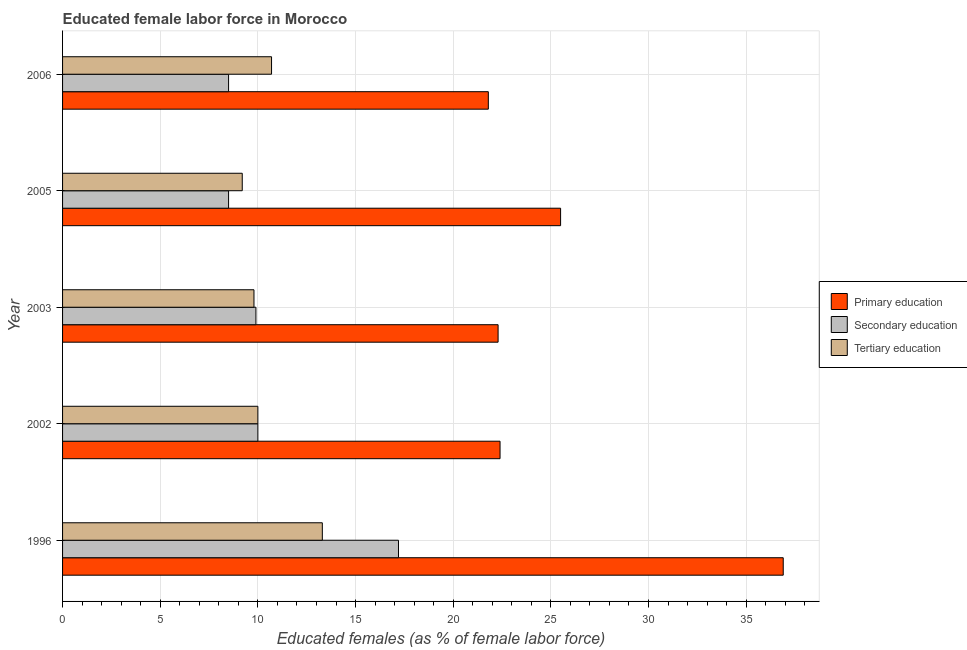How many different coloured bars are there?
Your answer should be very brief. 3. How many groups of bars are there?
Provide a succinct answer. 5. How many bars are there on the 5th tick from the bottom?
Your answer should be very brief. 3. What is the label of the 5th group of bars from the top?
Make the answer very short. 1996. What is the percentage of female labor force who received secondary education in 1996?
Provide a short and direct response. 17.2. Across all years, what is the maximum percentage of female labor force who received tertiary education?
Provide a short and direct response. 13.3. Across all years, what is the minimum percentage of female labor force who received secondary education?
Your answer should be very brief. 8.5. In which year was the percentage of female labor force who received tertiary education minimum?
Your response must be concise. 2005. What is the total percentage of female labor force who received tertiary education in the graph?
Your answer should be compact. 53. What is the difference between the percentage of female labor force who received primary education in 2005 and the percentage of female labor force who received tertiary education in 1996?
Your answer should be compact. 12.2. What is the average percentage of female labor force who received secondary education per year?
Offer a very short reply. 10.82. In the year 1996, what is the difference between the percentage of female labor force who received secondary education and percentage of female labor force who received primary education?
Your answer should be compact. -19.7. What is the ratio of the percentage of female labor force who received tertiary education in 2003 to that in 2006?
Make the answer very short. 0.92. Is the percentage of female labor force who received secondary education in 2002 less than that in 2003?
Your answer should be very brief. No. Is the difference between the percentage of female labor force who received tertiary education in 1996 and 2002 greater than the difference between the percentage of female labor force who received secondary education in 1996 and 2002?
Offer a terse response. No. What is the difference between the highest and the second highest percentage of female labor force who received secondary education?
Make the answer very short. 7.2. What is the difference between the highest and the lowest percentage of female labor force who received primary education?
Provide a succinct answer. 15.1. What does the 1st bar from the bottom in 1996 represents?
Your answer should be compact. Primary education. Is it the case that in every year, the sum of the percentage of female labor force who received primary education and percentage of female labor force who received secondary education is greater than the percentage of female labor force who received tertiary education?
Offer a very short reply. Yes. How many years are there in the graph?
Ensure brevity in your answer.  5. What is the difference between two consecutive major ticks on the X-axis?
Your answer should be very brief. 5. Are the values on the major ticks of X-axis written in scientific E-notation?
Keep it short and to the point. No. Does the graph contain any zero values?
Your answer should be compact. No. Where does the legend appear in the graph?
Keep it short and to the point. Center right. What is the title of the graph?
Offer a terse response. Educated female labor force in Morocco. What is the label or title of the X-axis?
Offer a terse response. Educated females (as % of female labor force). What is the Educated females (as % of female labor force) in Primary education in 1996?
Your answer should be very brief. 36.9. What is the Educated females (as % of female labor force) of Secondary education in 1996?
Give a very brief answer. 17.2. What is the Educated females (as % of female labor force) of Tertiary education in 1996?
Ensure brevity in your answer.  13.3. What is the Educated females (as % of female labor force) of Primary education in 2002?
Make the answer very short. 22.4. What is the Educated females (as % of female labor force) in Tertiary education in 2002?
Your answer should be very brief. 10. What is the Educated females (as % of female labor force) in Primary education in 2003?
Offer a very short reply. 22.3. What is the Educated females (as % of female labor force) of Secondary education in 2003?
Provide a succinct answer. 9.9. What is the Educated females (as % of female labor force) in Tertiary education in 2003?
Make the answer very short. 9.8. What is the Educated females (as % of female labor force) of Primary education in 2005?
Give a very brief answer. 25.5. What is the Educated females (as % of female labor force) in Secondary education in 2005?
Keep it short and to the point. 8.5. What is the Educated females (as % of female labor force) in Tertiary education in 2005?
Ensure brevity in your answer.  9.2. What is the Educated females (as % of female labor force) in Primary education in 2006?
Give a very brief answer. 21.8. What is the Educated females (as % of female labor force) of Secondary education in 2006?
Your answer should be very brief. 8.5. What is the Educated females (as % of female labor force) in Tertiary education in 2006?
Your answer should be very brief. 10.7. Across all years, what is the maximum Educated females (as % of female labor force) in Primary education?
Offer a terse response. 36.9. Across all years, what is the maximum Educated females (as % of female labor force) in Secondary education?
Give a very brief answer. 17.2. Across all years, what is the maximum Educated females (as % of female labor force) of Tertiary education?
Your answer should be compact. 13.3. Across all years, what is the minimum Educated females (as % of female labor force) in Primary education?
Your response must be concise. 21.8. Across all years, what is the minimum Educated females (as % of female labor force) of Secondary education?
Your answer should be compact. 8.5. Across all years, what is the minimum Educated females (as % of female labor force) of Tertiary education?
Provide a short and direct response. 9.2. What is the total Educated females (as % of female labor force) of Primary education in the graph?
Make the answer very short. 128.9. What is the total Educated females (as % of female labor force) in Secondary education in the graph?
Your answer should be compact. 54.1. What is the total Educated females (as % of female labor force) in Tertiary education in the graph?
Ensure brevity in your answer.  53. What is the difference between the Educated females (as % of female labor force) in Tertiary education in 1996 and that in 2002?
Offer a terse response. 3.3. What is the difference between the Educated females (as % of female labor force) in Primary education in 1996 and that in 2003?
Your answer should be very brief. 14.6. What is the difference between the Educated females (as % of female labor force) of Primary education in 1996 and that in 2005?
Make the answer very short. 11.4. What is the difference between the Educated females (as % of female labor force) of Tertiary education in 1996 and that in 2005?
Your answer should be compact. 4.1. What is the difference between the Educated females (as % of female labor force) in Primary education in 1996 and that in 2006?
Offer a very short reply. 15.1. What is the difference between the Educated females (as % of female labor force) of Secondary education in 1996 and that in 2006?
Offer a very short reply. 8.7. What is the difference between the Educated females (as % of female labor force) in Tertiary education in 1996 and that in 2006?
Offer a very short reply. 2.6. What is the difference between the Educated females (as % of female labor force) of Tertiary education in 2002 and that in 2005?
Your answer should be very brief. 0.8. What is the difference between the Educated females (as % of female labor force) of Primary education in 2002 and that in 2006?
Make the answer very short. 0.6. What is the difference between the Educated females (as % of female labor force) in Primary education in 2003 and that in 2005?
Offer a terse response. -3.2. What is the difference between the Educated females (as % of female labor force) of Primary education in 2003 and that in 2006?
Your answer should be compact. 0.5. What is the difference between the Educated females (as % of female labor force) in Secondary education in 2003 and that in 2006?
Provide a short and direct response. 1.4. What is the difference between the Educated females (as % of female labor force) in Primary education in 2005 and that in 2006?
Make the answer very short. 3.7. What is the difference between the Educated females (as % of female labor force) in Secondary education in 2005 and that in 2006?
Your answer should be very brief. 0. What is the difference between the Educated females (as % of female labor force) of Tertiary education in 2005 and that in 2006?
Your response must be concise. -1.5. What is the difference between the Educated females (as % of female labor force) in Primary education in 1996 and the Educated females (as % of female labor force) in Secondary education in 2002?
Make the answer very short. 26.9. What is the difference between the Educated females (as % of female labor force) in Primary education in 1996 and the Educated females (as % of female labor force) in Tertiary education in 2002?
Offer a very short reply. 26.9. What is the difference between the Educated females (as % of female labor force) in Primary education in 1996 and the Educated females (as % of female labor force) in Secondary education in 2003?
Offer a terse response. 27. What is the difference between the Educated females (as % of female labor force) in Primary education in 1996 and the Educated females (as % of female labor force) in Tertiary education in 2003?
Offer a very short reply. 27.1. What is the difference between the Educated females (as % of female labor force) of Secondary education in 1996 and the Educated females (as % of female labor force) of Tertiary education in 2003?
Offer a terse response. 7.4. What is the difference between the Educated females (as % of female labor force) in Primary education in 1996 and the Educated females (as % of female labor force) in Secondary education in 2005?
Provide a succinct answer. 28.4. What is the difference between the Educated females (as % of female labor force) in Primary education in 1996 and the Educated females (as % of female labor force) in Tertiary education in 2005?
Keep it short and to the point. 27.7. What is the difference between the Educated females (as % of female labor force) of Secondary education in 1996 and the Educated females (as % of female labor force) of Tertiary education in 2005?
Provide a short and direct response. 8. What is the difference between the Educated females (as % of female labor force) of Primary education in 1996 and the Educated females (as % of female labor force) of Secondary education in 2006?
Provide a succinct answer. 28.4. What is the difference between the Educated females (as % of female labor force) of Primary education in 1996 and the Educated females (as % of female labor force) of Tertiary education in 2006?
Give a very brief answer. 26.2. What is the difference between the Educated females (as % of female labor force) in Secondary education in 1996 and the Educated females (as % of female labor force) in Tertiary education in 2006?
Keep it short and to the point. 6.5. What is the difference between the Educated females (as % of female labor force) of Primary education in 2002 and the Educated females (as % of female labor force) of Tertiary education in 2003?
Your answer should be compact. 12.6. What is the difference between the Educated females (as % of female labor force) of Secondary education in 2002 and the Educated females (as % of female labor force) of Tertiary education in 2003?
Provide a short and direct response. 0.2. What is the difference between the Educated females (as % of female labor force) in Primary education in 2002 and the Educated females (as % of female labor force) in Tertiary education in 2005?
Offer a very short reply. 13.2. What is the difference between the Educated females (as % of female labor force) in Secondary education in 2002 and the Educated females (as % of female labor force) in Tertiary education in 2005?
Provide a short and direct response. 0.8. What is the difference between the Educated females (as % of female labor force) in Primary education in 2003 and the Educated females (as % of female labor force) in Secondary education in 2005?
Ensure brevity in your answer.  13.8. What is the difference between the Educated females (as % of female labor force) in Secondary education in 2003 and the Educated females (as % of female labor force) in Tertiary education in 2006?
Your response must be concise. -0.8. What is the difference between the Educated females (as % of female labor force) in Primary education in 2005 and the Educated females (as % of female labor force) in Secondary education in 2006?
Offer a terse response. 17. What is the average Educated females (as % of female labor force) in Primary education per year?
Provide a succinct answer. 25.78. What is the average Educated females (as % of female labor force) of Secondary education per year?
Your answer should be compact. 10.82. In the year 1996, what is the difference between the Educated females (as % of female labor force) in Primary education and Educated females (as % of female labor force) in Tertiary education?
Keep it short and to the point. 23.6. In the year 1996, what is the difference between the Educated females (as % of female labor force) in Secondary education and Educated females (as % of female labor force) in Tertiary education?
Your response must be concise. 3.9. In the year 2003, what is the difference between the Educated females (as % of female labor force) in Secondary education and Educated females (as % of female labor force) in Tertiary education?
Offer a terse response. 0.1. In the year 2005, what is the difference between the Educated females (as % of female labor force) in Primary education and Educated females (as % of female labor force) in Secondary education?
Your answer should be compact. 17. In the year 2005, what is the difference between the Educated females (as % of female labor force) of Primary education and Educated females (as % of female labor force) of Tertiary education?
Ensure brevity in your answer.  16.3. In the year 2006, what is the difference between the Educated females (as % of female labor force) of Primary education and Educated females (as % of female labor force) of Secondary education?
Give a very brief answer. 13.3. In the year 2006, what is the difference between the Educated females (as % of female labor force) of Primary education and Educated females (as % of female labor force) of Tertiary education?
Offer a terse response. 11.1. In the year 2006, what is the difference between the Educated females (as % of female labor force) of Secondary education and Educated females (as % of female labor force) of Tertiary education?
Your response must be concise. -2.2. What is the ratio of the Educated females (as % of female labor force) in Primary education in 1996 to that in 2002?
Offer a terse response. 1.65. What is the ratio of the Educated females (as % of female labor force) of Secondary education in 1996 to that in 2002?
Provide a short and direct response. 1.72. What is the ratio of the Educated females (as % of female labor force) in Tertiary education in 1996 to that in 2002?
Provide a short and direct response. 1.33. What is the ratio of the Educated females (as % of female labor force) of Primary education in 1996 to that in 2003?
Your answer should be very brief. 1.65. What is the ratio of the Educated females (as % of female labor force) in Secondary education in 1996 to that in 2003?
Offer a terse response. 1.74. What is the ratio of the Educated females (as % of female labor force) in Tertiary education in 1996 to that in 2003?
Keep it short and to the point. 1.36. What is the ratio of the Educated females (as % of female labor force) of Primary education in 1996 to that in 2005?
Make the answer very short. 1.45. What is the ratio of the Educated females (as % of female labor force) in Secondary education in 1996 to that in 2005?
Give a very brief answer. 2.02. What is the ratio of the Educated females (as % of female labor force) of Tertiary education in 1996 to that in 2005?
Provide a succinct answer. 1.45. What is the ratio of the Educated females (as % of female labor force) in Primary education in 1996 to that in 2006?
Your response must be concise. 1.69. What is the ratio of the Educated females (as % of female labor force) of Secondary education in 1996 to that in 2006?
Make the answer very short. 2.02. What is the ratio of the Educated females (as % of female labor force) of Tertiary education in 1996 to that in 2006?
Provide a succinct answer. 1.24. What is the ratio of the Educated females (as % of female labor force) in Primary education in 2002 to that in 2003?
Give a very brief answer. 1. What is the ratio of the Educated females (as % of female labor force) of Secondary education in 2002 to that in 2003?
Ensure brevity in your answer.  1.01. What is the ratio of the Educated females (as % of female labor force) of Tertiary education in 2002 to that in 2003?
Make the answer very short. 1.02. What is the ratio of the Educated females (as % of female labor force) in Primary education in 2002 to that in 2005?
Ensure brevity in your answer.  0.88. What is the ratio of the Educated females (as % of female labor force) in Secondary education in 2002 to that in 2005?
Provide a succinct answer. 1.18. What is the ratio of the Educated females (as % of female labor force) of Tertiary education in 2002 to that in 2005?
Provide a short and direct response. 1.09. What is the ratio of the Educated females (as % of female labor force) in Primary education in 2002 to that in 2006?
Provide a succinct answer. 1.03. What is the ratio of the Educated females (as % of female labor force) in Secondary education in 2002 to that in 2006?
Offer a terse response. 1.18. What is the ratio of the Educated females (as % of female labor force) in Tertiary education in 2002 to that in 2006?
Keep it short and to the point. 0.93. What is the ratio of the Educated females (as % of female labor force) in Primary education in 2003 to that in 2005?
Provide a short and direct response. 0.87. What is the ratio of the Educated females (as % of female labor force) in Secondary education in 2003 to that in 2005?
Provide a succinct answer. 1.16. What is the ratio of the Educated females (as % of female labor force) of Tertiary education in 2003 to that in 2005?
Provide a short and direct response. 1.07. What is the ratio of the Educated females (as % of female labor force) in Primary education in 2003 to that in 2006?
Ensure brevity in your answer.  1.02. What is the ratio of the Educated females (as % of female labor force) of Secondary education in 2003 to that in 2006?
Your response must be concise. 1.16. What is the ratio of the Educated females (as % of female labor force) in Tertiary education in 2003 to that in 2006?
Provide a succinct answer. 0.92. What is the ratio of the Educated females (as % of female labor force) in Primary education in 2005 to that in 2006?
Give a very brief answer. 1.17. What is the ratio of the Educated females (as % of female labor force) of Tertiary education in 2005 to that in 2006?
Keep it short and to the point. 0.86. What is the difference between the highest and the second highest Educated females (as % of female labor force) in Primary education?
Offer a terse response. 11.4. What is the difference between the highest and the second highest Educated females (as % of female labor force) in Tertiary education?
Give a very brief answer. 2.6. What is the difference between the highest and the lowest Educated females (as % of female labor force) of Secondary education?
Provide a succinct answer. 8.7. What is the difference between the highest and the lowest Educated females (as % of female labor force) of Tertiary education?
Provide a succinct answer. 4.1. 